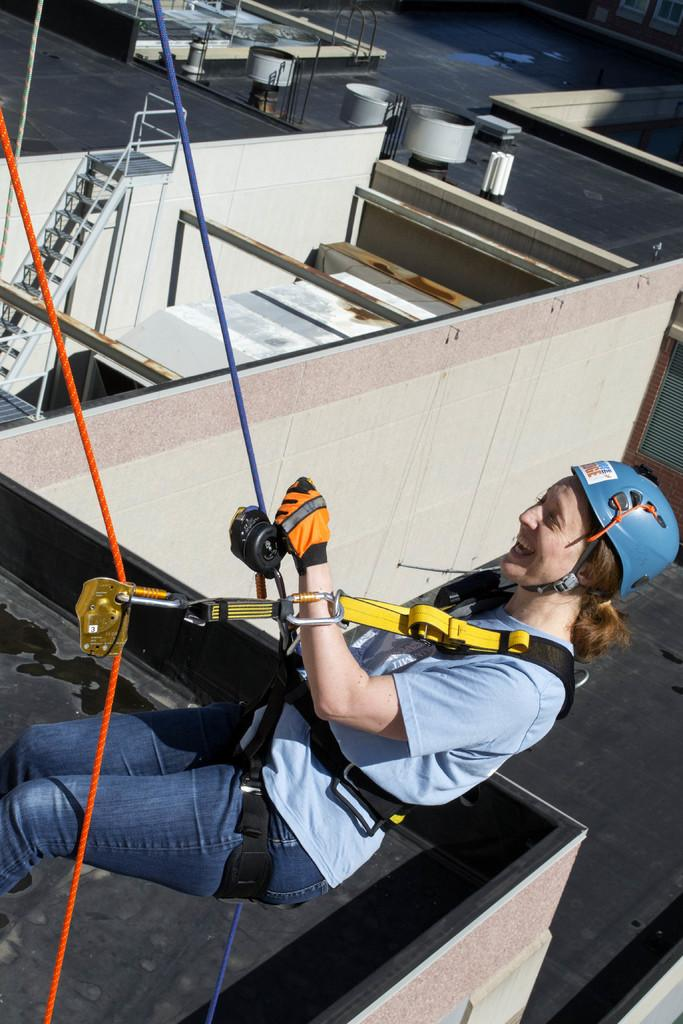What is the main subject of the image? There is a person in the image. What is the person doing in the image? The person is on ropes. What color is the person's top? The person is wearing a blue top. What type of pants is the person wearing? The person is wearing jeans. What type of protective gear is the person wearing? The person is wearing a blue helmet. What can be seen in the background of the image? There is a building, objects on the terrace, and stairs in the background of the image. What type of bears can be seen playing in the waves in the image? There are no bears or waves present in the image; it features a person on ropes with a background of a building, objects on the terrace, and stairs. 